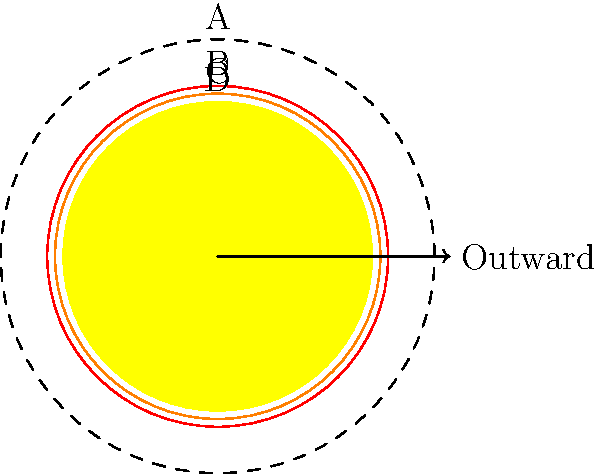In the cross-sectional diagram of the Sun's atmosphere, identify the layers labeled A, B, C, and D from outermost to innermost. How does this structure relate to the temperature gradient in the solar atmosphere? To identify the layers of the Sun's atmosphere and understand their relation to the temperature gradient, let's follow these steps:

1. Identify the layers from outermost to innermost:
   A: Corona (outermost layer)
   B: Chromosphere
   C: Photosphere
   D: Solar surface (innermost visible layer)

2. Temperature gradient:
   - The temperature actually increases as we move outward from the photosphere to the corona, which is counterintuitive.
   - Photosphere (C): Temperature is about 5800 K
   - Chromosphere (B): Temperature rises to about 20,000 K
   - Corona (A): Temperature reaches millions of degrees Kelvin

3. Explanation of the temperature gradient:
   - This phenomenon is known as the coronal heating problem.
   - It's believed to be caused by magnetic reconnection and wave heating in the upper layers of the Sun's atmosphere.
   - The exact mechanisms are still a subject of ongoing research in solar physics.

4. Characteristics of each layer:
   - Corona (A): Extremely hot and tenuous, visible during solar eclipses
   - Chromosphere (B): Reddish layer, visible during eclipses and with special filters
   - Photosphere (C): The visible "surface" of the Sun, source of most solar radiation
   - Solar surface (D): Not a distinct layer, but the boundary between the interior and atmosphere

5. Importance in academic formatting:
   - When creating diagrams or citing solar atmospheric data, it's crucial to use consistent labeling and accurate temperature values from peer-reviewed sources.
   - Proper citation of solar physics literature is essential in academic writing on this topic.
Answer: A: Corona, B: Chromosphere, C: Photosphere, D: Solar surface. Temperature increases from C to A. 